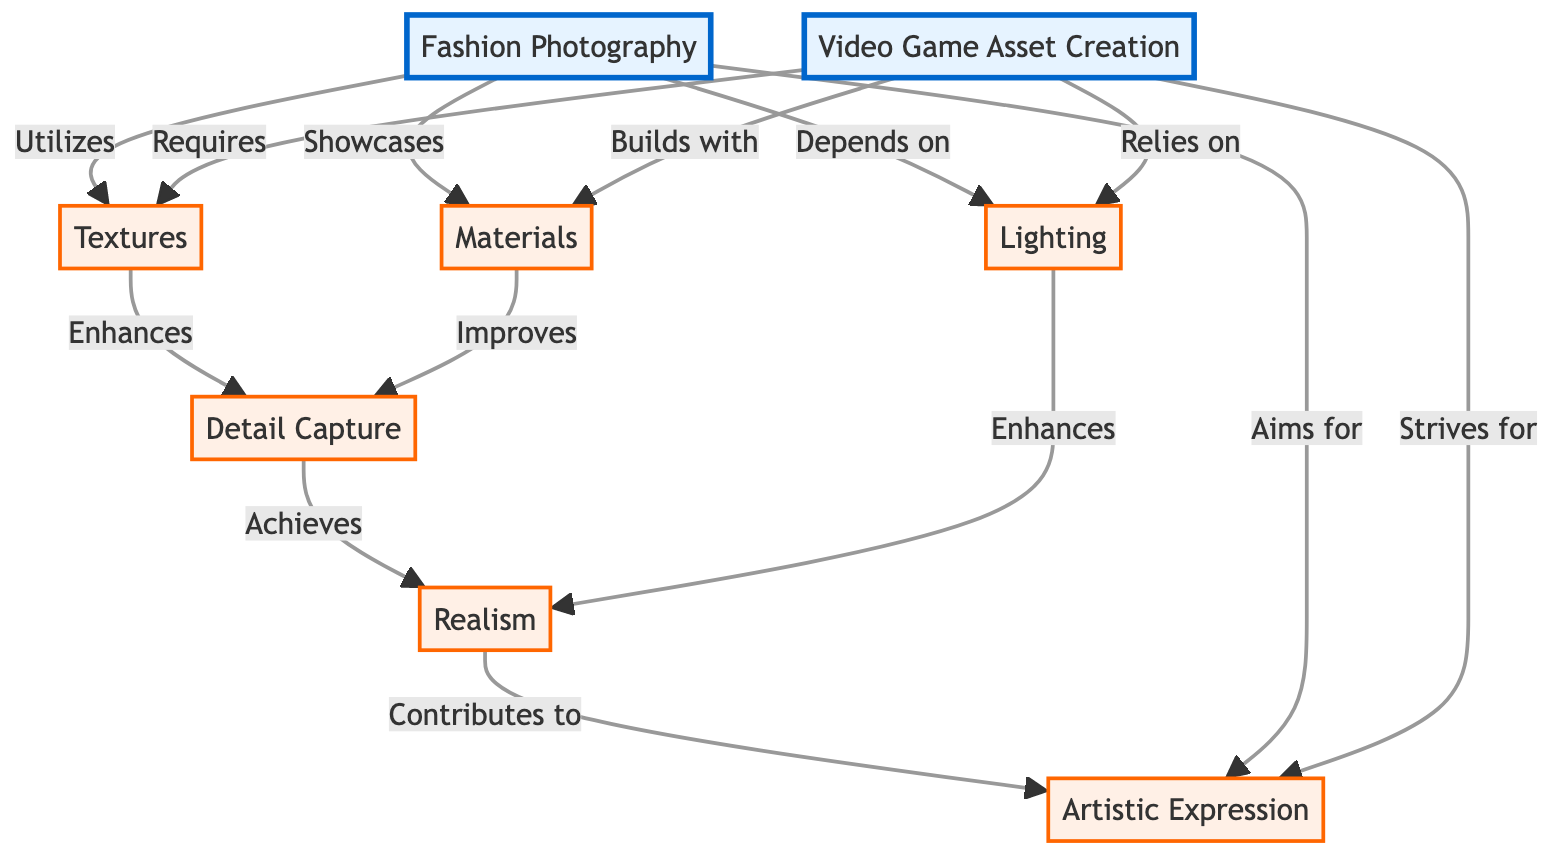What's the main focus of Fashion Photography? The diagram shows that Fashion Photography aims for ArtisticExpression, indicating its primary focus on artistic elements.
Answer: Artistic Expression How do textures affect detail capture in Video Game Asset Creation? According to the diagram, Textures enhance DetailCapture, suggesting that they improve the ability to capture intricate aspects in video game objects.
Answer: Enhances What is one of the key elements that both Fashion Photography and Video Game Asset Creation rely on? The diagram indicates that both rely on Lighting, which is crucial in both fields for achieving desired visual effects.
Answer: Lighting How many main nodes are there in the diagram? The diagram includes two main nodes: FashionPhotography and VideoGameAsset. Hence, the total count is two.
Answer: 2 What aspect of both Fashion Photography and Video Game Asset Creation contributes to realism? The diagram shows that DetailCapture contributes to Realism in both areas, indicating its importance in creating believable visuals.
Answer: Contributes to In which area are materials showcased according to the diagram? The diagram states that Fashion Photography showcases Materials, pointing to the importance of materials in the visual portrayal of fashion.
Answer: Fashion Photography What do both Fashion Photography and Video Game Asset Creation strive for? The diagram notes that both aim for Artistic Expression, emphasizing their shared goal of creating visually artistic outputs.
Answer: Artistic Expression Which node does Fashion Photography depend on? The diagram clearly outlines that Fashion Photography depends on Lighting, showcasing its critical role in this field.
Answer: Lighting What role do materials play in Video Game Asset Creation? The diagram indicates that Materials improve DetailCapture in Video Game Asset Creation, highlighting their function in enhancing visual fidelity.
Answer: Improves 